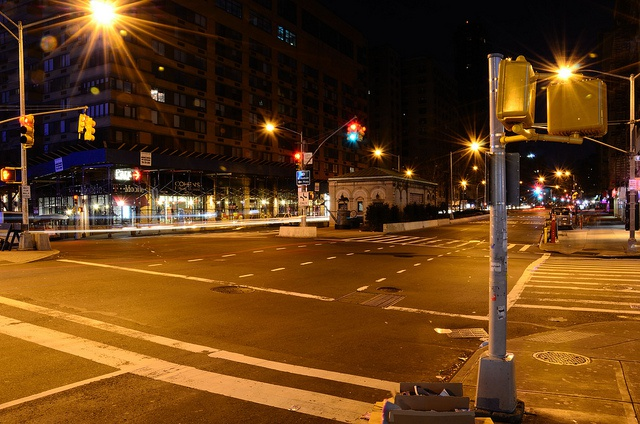Describe the objects in this image and their specific colors. I can see traffic light in navy, black, orange, brown, and red tones, car in navy, black, maroon, and brown tones, traffic light in navy, orange, gold, and olive tones, traffic light in navy, ivory, cyan, red, and salmon tones, and traffic light in navy, red, brown, and maroon tones in this image. 